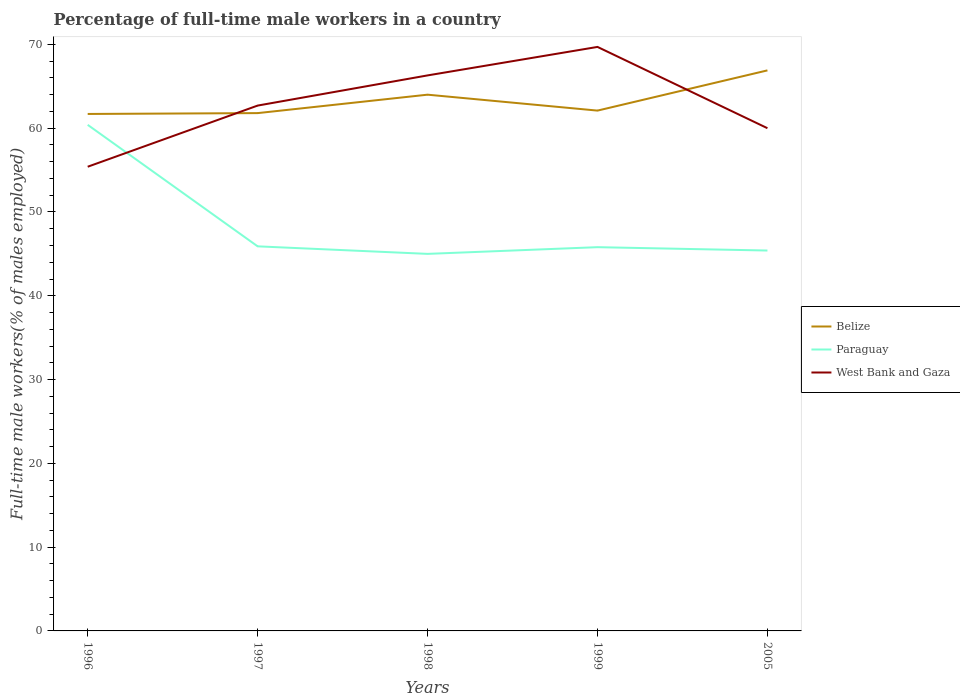Does the line corresponding to Paraguay intersect with the line corresponding to West Bank and Gaza?
Make the answer very short. Yes. Is the number of lines equal to the number of legend labels?
Offer a terse response. Yes. Across all years, what is the maximum percentage of full-time male workers in Belize?
Offer a terse response. 61.7. In which year was the percentage of full-time male workers in Paraguay maximum?
Keep it short and to the point. 1998. What is the total percentage of full-time male workers in Belize in the graph?
Provide a short and direct response. -4.8. What is the difference between the highest and the second highest percentage of full-time male workers in Belize?
Your answer should be compact. 5.2. What is the difference between the highest and the lowest percentage of full-time male workers in Paraguay?
Your response must be concise. 1. Is the percentage of full-time male workers in Belize strictly greater than the percentage of full-time male workers in West Bank and Gaza over the years?
Give a very brief answer. No. How many lines are there?
Provide a short and direct response. 3. How many years are there in the graph?
Your answer should be compact. 5. What is the difference between two consecutive major ticks on the Y-axis?
Ensure brevity in your answer.  10. Are the values on the major ticks of Y-axis written in scientific E-notation?
Your answer should be compact. No. What is the title of the graph?
Make the answer very short. Percentage of full-time male workers in a country. Does "Latvia" appear as one of the legend labels in the graph?
Give a very brief answer. No. What is the label or title of the Y-axis?
Ensure brevity in your answer.  Full-time male workers(% of males employed). What is the Full-time male workers(% of males employed) in Belize in 1996?
Keep it short and to the point. 61.7. What is the Full-time male workers(% of males employed) of Paraguay in 1996?
Your answer should be very brief. 60.4. What is the Full-time male workers(% of males employed) of West Bank and Gaza in 1996?
Your answer should be very brief. 55.4. What is the Full-time male workers(% of males employed) in Belize in 1997?
Make the answer very short. 61.8. What is the Full-time male workers(% of males employed) of Paraguay in 1997?
Provide a succinct answer. 45.9. What is the Full-time male workers(% of males employed) in West Bank and Gaza in 1997?
Your response must be concise. 62.7. What is the Full-time male workers(% of males employed) in Belize in 1998?
Your answer should be very brief. 64. What is the Full-time male workers(% of males employed) in Paraguay in 1998?
Your answer should be very brief. 45. What is the Full-time male workers(% of males employed) in West Bank and Gaza in 1998?
Provide a short and direct response. 66.3. What is the Full-time male workers(% of males employed) of Belize in 1999?
Your answer should be compact. 62.1. What is the Full-time male workers(% of males employed) in Paraguay in 1999?
Your answer should be compact. 45.8. What is the Full-time male workers(% of males employed) in West Bank and Gaza in 1999?
Give a very brief answer. 69.7. What is the Full-time male workers(% of males employed) of Belize in 2005?
Your response must be concise. 66.9. What is the Full-time male workers(% of males employed) in Paraguay in 2005?
Offer a terse response. 45.4. What is the Full-time male workers(% of males employed) in West Bank and Gaza in 2005?
Keep it short and to the point. 60. Across all years, what is the maximum Full-time male workers(% of males employed) of Belize?
Your answer should be very brief. 66.9. Across all years, what is the maximum Full-time male workers(% of males employed) in Paraguay?
Make the answer very short. 60.4. Across all years, what is the maximum Full-time male workers(% of males employed) in West Bank and Gaza?
Ensure brevity in your answer.  69.7. Across all years, what is the minimum Full-time male workers(% of males employed) in Belize?
Make the answer very short. 61.7. Across all years, what is the minimum Full-time male workers(% of males employed) of West Bank and Gaza?
Keep it short and to the point. 55.4. What is the total Full-time male workers(% of males employed) of Belize in the graph?
Your answer should be compact. 316.5. What is the total Full-time male workers(% of males employed) of Paraguay in the graph?
Your answer should be very brief. 242.5. What is the total Full-time male workers(% of males employed) of West Bank and Gaza in the graph?
Provide a short and direct response. 314.1. What is the difference between the Full-time male workers(% of males employed) of Belize in 1996 and that in 1997?
Give a very brief answer. -0.1. What is the difference between the Full-time male workers(% of males employed) in Paraguay in 1996 and that in 1998?
Ensure brevity in your answer.  15.4. What is the difference between the Full-time male workers(% of males employed) of West Bank and Gaza in 1996 and that in 1998?
Offer a terse response. -10.9. What is the difference between the Full-time male workers(% of males employed) of West Bank and Gaza in 1996 and that in 1999?
Ensure brevity in your answer.  -14.3. What is the difference between the Full-time male workers(% of males employed) of Belize in 1996 and that in 2005?
Keep it short and to the point. -5.2. What is the difference between the Full-time male workers(% of males employed) in Paraguay in 1996 and that in 2005?
Give a very brief answer. 15. What is the difference between the Full-time male workers(% of males employed) in Belize in 1997 and that in 1998?
Provide a succinct answer. -2.2. What is the difference between the Full-time male workers(% of males employed) of Paraguay in 1997 and that in 1998?
Your answer should be compact. 0.9. What is the difference between the Full-time male workers(% of males employed) of West Bank and Gaza in 1997 and that in 1998?
Make the answer very short. -3.6. What is the difference between the Full-time male workers(% of males employed) in Belize in 1997 and that in 1999?
Offer a terse response. -0.3. What is the difference between the Full-time male workers(% of males employed) of Paraguay in 1997 and that in 1999?
Offer a very short reply. 0.1. What is the difference between the Full-time male workers(% of males employed) in West Bank and Gaza in 1997 and that in 1999?
Offer a terse response. -7. What is the difference between the Full-time male workers(% of males employed) in Paraguay in 1997 and that in 2005?
Your answer should be compact. 0.5. What is the difference between the Full-time male workers(% of males employed) of Belize in 1998 and that in 1999?
Offer a terse response. 1.9. What is the difference between the Full-time male workers(% of males employed) of Belize in 1998 and that in 2005?
Provide a short and direct response. -2.9. What is the difference between the Full-time male workers(% of males employed) of West Bank and Gaza in 1998 and that in 2005?
Provide a succinct answer. 6.3. What is the difference between the Full-time male workers(% of males employed) in Paraguay in 1999 and that in 2005?
Provide a short and direct response. 0.4. What is the difference between the Full-time male workers(% of males employed) in West Bank and Gaza in 1999 and that in 2005?
Your answer should be compact. 9.7. What is the difference between the Full-time male workers(% of males employed) in Belize in 1996 and the Full-time male workers(% of males employed) in Paraguay in 1997?
Your response must be concise. 15.8. What is the difference between the Full-time male workers(% of males employed) in Belize in 1996 and the Full-time male workers(% of males employed) in West Bank and Gaza in 1998?
Keep it short and to the point. -4.6. What is the difference between the Full-time male workers(% of males employed) in Paraguay in 1996 and the Full-time male workers(% of males employed) in West Bank and Gaza in 1998?
Keep it short and to the point. -5.9. What is the difference between the Full-time male workers(% of males employed) of Paraguay in 1996 and the Full-time male workers(% of males employed) of West Bank and Gaza in 1999?
Give a very brief answer. -9.3. What is the difference between the Full-time male workers(% of males employed) in Belize in 1996 and the Full-time male workers(% of males employed) in Paraguay in 2005?
Provide a short and direct response. 16.3. What is the difference between the Full-time male workers(% of males employed) of Belize in 1996 and the Full-time male workers(% of males employed) of West Bank and Gaza in 2005?
Provide a succinct answer. 1.7. What is the difference between the Full-time male workers(% of males employed) of Belize in 1997 and the Full-time male workers(% of males employed) of Paraguay in 1998?
Your response must be concise. 16.8. What is the difference between the Full-time male workers(% of males employed) in Belize in 1997 and the Full-time male workers(% of males employed) in West Bank and Gaza in 1998?
Give a very brief answer. -4.5. What is the difference between the Full-time male workers(% of males employed) of Paraguay in 1997 and the Full-time male workers(% of males employed) of West Bank and Gaza in 1998?
Offer a very short reply. -20.4. What is the difference between the Full-time male workers(% of males employed) of Belize in 1997 and the Full-time male workers(% of males employed) of Paraguay in 1999?
Your answer should be very brief. 16. What is the difference between the Full-time male workers(% of males employed) of Paraguay in 1997 and the Full-time male workers(% of males employed) of West Bank and Gaza in 1999?
Offer a terse response. -23.8. What is the difference between the Full-time male workers(% of males employed) in Paraguay in 1997 and the Full-time male workers(% of males employed) in West Bank and Gaza in 2005?
Your answer should be very brief. -14.1. What is the difference between the Full-time male workers(% of males employed) in Paraguay in 1998 and the Full-time male workers(% of males employed) in West Bank and Gaza in 1999?
Make the answer very short. -24.7. What is the difference between the Full-time male workers(% of males employed) in Paraguay in 1998 and the Full-time male workers(% of males employed) in West Bank and Gaza in 2005?
Ensure brevity in your answer.  -15. What is the difference between the Full-time male workers(% of males employed) of Belize in 1999 and the Full-time male workers(% of males employed) of Paraguay in 2005?
Give a very brief answer. 16.7. What is the difference between the Full-time male workers(% of males employed) in Paraguay in 1999 and the Full-time male workers(% of males employed) in West Bank and Gaza in 2005?
Make the answer very short. -14.2. What is the average Full-time male workers(% of males employed) in Belize per year?
Offer a terse response. 63.3. What is the average Full-time male workers(% of males employed) in Paraguay per year?
Your answer should be very brief. 48.5. What is the average Full-time male workers(% of males employed) of West Bank and Gaza per year?
Provide a succinct answer. 62.82. In the year 1996, what is the difference between the Full-time male workers(% of males employed) of Belize and Full-time male workers(% of males employed) of West Bank and Gaza?
Your answer should be very brief. 6.3. In the year 1997, what is the difference between the Full-time male workers(% of males employed) of Belize and Full-time male workers(% of males employed) of Paraguay?
Your answer should be compact. 15.9. In the year 1997, what is the difference between the Full-time male workers(% of males employed) in Paraguay and Full-time male workers(% of males employed) in West Bank and Gaza?
Your answer should be very brief. -16.8. In the year 1998, what is the difference between the Full-time male workers(% of males employed) of Belize and Full-time male workers(% of males employed) of Paraguay?
Your answer should be very brief. 19. In the year 1998, what is the difference between the Full-time male workers(% of males employed) in Paraguay and Full-time male workers(% of males employed) in West Bank and Gaza?
Your answer should be very brief. -21.3. In the year 1999, what is the difference between the Full-time male workers(% of males employed) of Belize and Full-time male workers(% of males employed) of Paraguay?
Your answer should be compact. 16.3. In the year 1999, what is the difference between the Full-time male workers(% of males employed) in Paraguay and Full-time male workers(% of males employed) in West Bank and Gaza?
Offer a terse response. -23.9. In the year 2005, what is the difference between the Full-time male workers(% of males employed) of Belize and Full-time male workers(% of males employed) of Paraguay?
Give a very brief answer. 21.5. In the year 2005, what is the difference between the Full-time male workers(% of males employed) of Paraguay and Full-time male workers(% of males employed) of West Bank and Gaza?
Offer a very short reply. -14.6. What is the ratio of the Full-time male workers(% of males employed) in Belize in 1996 to that in 1997?
Ensure brevity in your answer.  1. What is the ratio of the Full-time male workers(% of males employed) of Paraguay in 1996 to that in 1997?
Your answer should be very brief. 1.32. What is the ratio of the Full-time male workers(% of males employed) in West Bank and Gaza in 1996 to that in 1997?
Offer a terse response. 0.88. What is the ratio of the Full-time male workers(% of males employed) of Belize in 1996 to that in 1998?
Provide a short and direct response. 0.96. What is the ratio of the Full-time male workers(% of males employed) of Paraguay in 1996 to that in 1998?
Provide a short and direct response. 1.34. What is the ratio of the Full-time male workers(% of males employed) in West Bank and Gaza in 1996 to that in 1998?
Make the answer very short. 0.84. What is the ratio of the Full-time male workers(% of males employed) in Belize in 1996 to that in 1999?
Ensure brevity in your answer.  0.99. What is the ratio of the Full-time male workers(% of males employed) of Paraguay in 1996 to that in 1999?
Make the answer very short. 1.32. What is the ratio of the Full-time male workers(% of males employed) in West Bank and Gaza in 1996 to that in 1999?
Ensure brevity in your answer.  0.79. What is the ratio of the Full-time male workers(% of males employed) of Belize in 1996 to that in 2005?
Provide a short and direct response. 0.92. What is the ratio of the Full-time male workers(% of males employed) of Paraguay in 1996 to that in 2005?
Offer a terse response. 1.33. What is the ratio of the Full-time male workers(% of males employed) of West Bank and Gaza in 1996 to that in 2005?
Your answer should be compact. 0.92. What is the ratio of the Full-time male workers(% of males employed) in Belize in 1997 to that in 1998?
Offer a very short reply. 0.97. What is the ratio of the Full-time male workers(% of males employed) in Paraguay in 1997 to that in 1998?
Your response must be concise. 1.02. What is the ratio of the Full-time male workers(% of males employed) in West Bank and Gaza in 1997 to that in 1998?
Ensure brevity in your answer.  0.95. What is the ratio of the Full-time male workers(% of males employed) of Belize in 1997 to that in 1999?
Offer a very short reply. 1. What is the ratio of the Full-time male workers(% of males employed) of West Bank and Gaza in 1997 to that in 1999?
Provide a succinct answer. 0.9. What is the ratio of the Full-time male workers(% of males employed) of Belize in 1997 to that in 2005?
Provide a short and direct response. 0.92. What is the ratio of the Full-time male workers(% of males employed) of Paraguay in 1997 to that in 2005?
Make the answer very short. 1.01. What is the ratio of the Full-time male workers(% of males employed) in West Bank and Gaza in 1997 to that in 2005?
Your response must be concise. 1.04. What is the ratio of the Full-time male workers(% of males employed) of Belize in 1998 to that in 1999?
Your response must be concise. 1.03. What is the ratio of the Full-time male workers(% of males employed) of Paraguay in 1998 to that in 1999?
Ensure brevity in your answer.  0.98. What is the ratio of the Full-time male workers(% of males employed) in West Bank and Gaza in 1998 to that in 1999?
Offer a very short reply. 0.95. What is the ratio of the Full-time male workers(% of males employed) of Belize in 1998 to that in 2005?
Ensure brevity in your answer.  0.96. What is the ratio of the Full-time male workers(% of males employed) of Paraguay in 1998 to that in 2005?
Offer a terse response. 0.99. What is the ratio of the Full-time male workers(% of males employed) of West Bank and Gaza in 1998 to that in 2005?
Give a very brief answer. 1.1. What is the ratio of the Full-time male workers(% of males employed) of Belize in 1999 to that in 2005?
Keep it short and to the point. 0.93. What is the ratio of the Full-time male workers(% of males employed) in Paraguay in 1999 to that in 2005?
Your answer should be very brief. 1.01. What is the ratio of the Full-time male workers(% of males employed) in West Bank and Gaza in 1999 to that in 2005?
Ensure brevity in your answer.  1.16. 